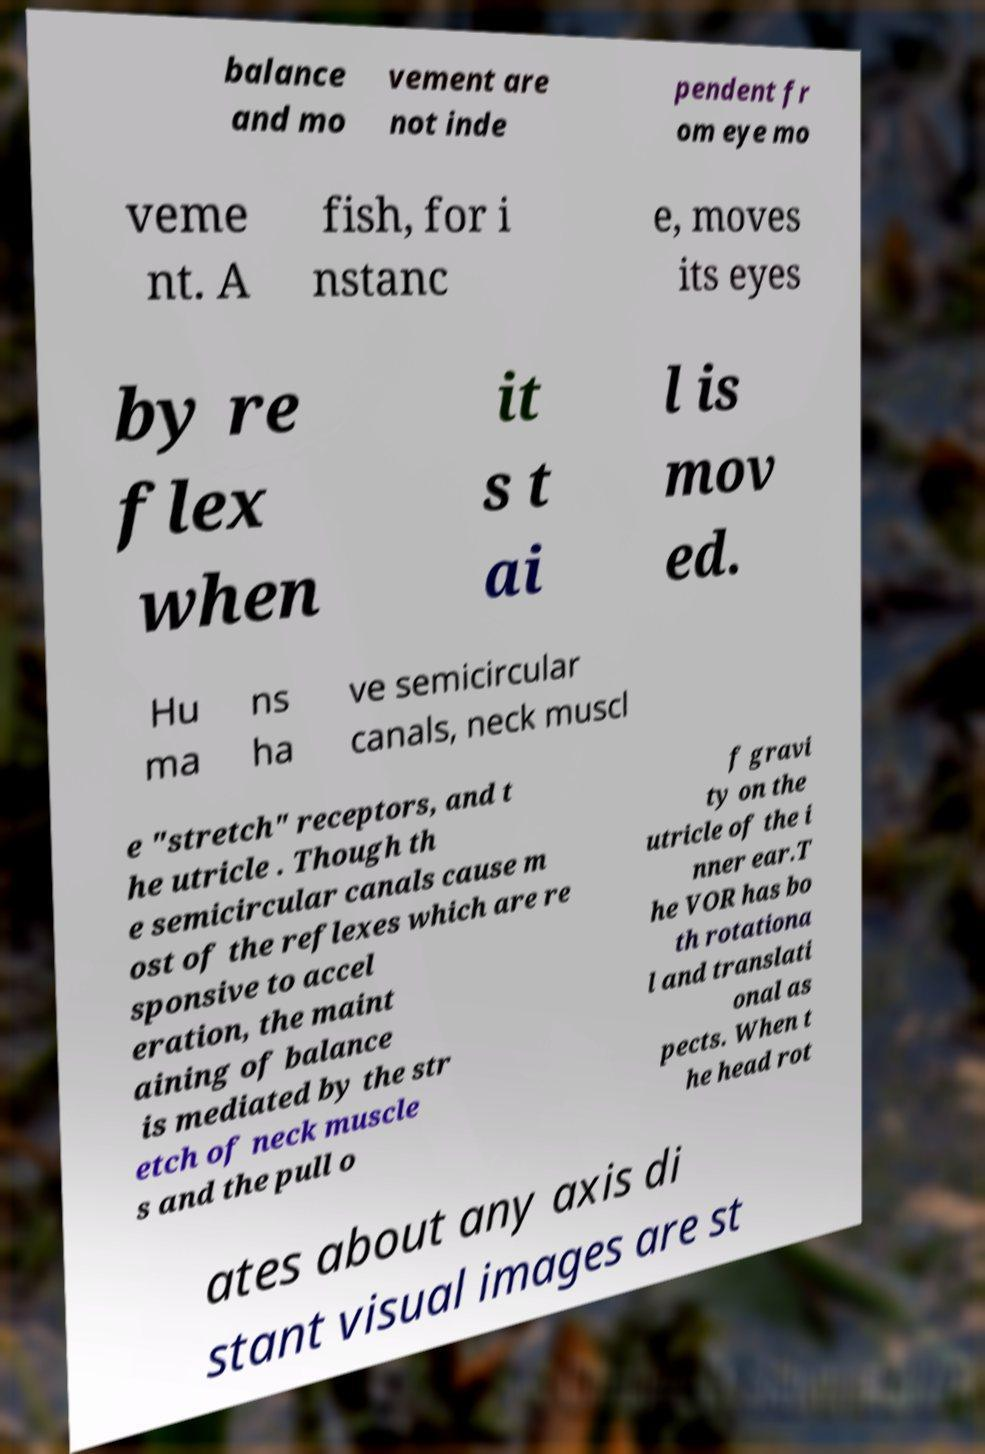There's text embedded in this image that I need extracted. Can you transcribe it verbatim? balance and mo vement are not inde pendent fr om eye mo veme nt. A fish, for i nstanc e, moves its eyes by re flex when it s t ai l is mov ed. Hu ma ns ha ve semicircular canals, neck muscl e "stretch" receptors, and t he utricle . Though th e semicircular canals cause m ost of the reflexes which are re sponsive to accel eration, the maint aining of balance is mediated by the str etch of neck muscle s and the pull o f gravi ty on the utricle of the i nner ear.T he VOR has bo th rotationa l and translati onal as pects. When t he head rot ates about any axis di stant visual images are st 